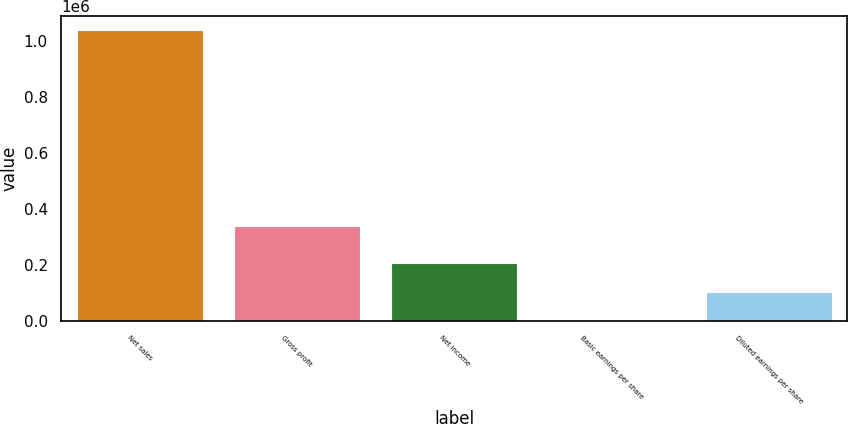<chart> <loc_0><loc_0><loc_500><loc_500><bar_chart><fcel>Net sales<fcel>Gross profit<fcel>Net income<fcel>Basic earnings per share<fcel>Diluted earnings per share<nl><fcel>1.03989e+06<fcel>339679<fcel>207979<fcel>0.12<fcel>103990<nl></chart> 